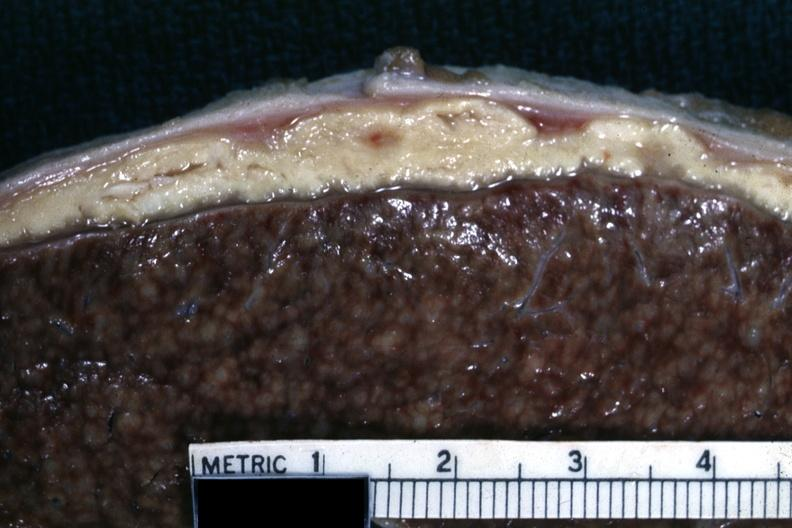how is this cold abscess material?
Answer the question using a single word or phrase. Typical 